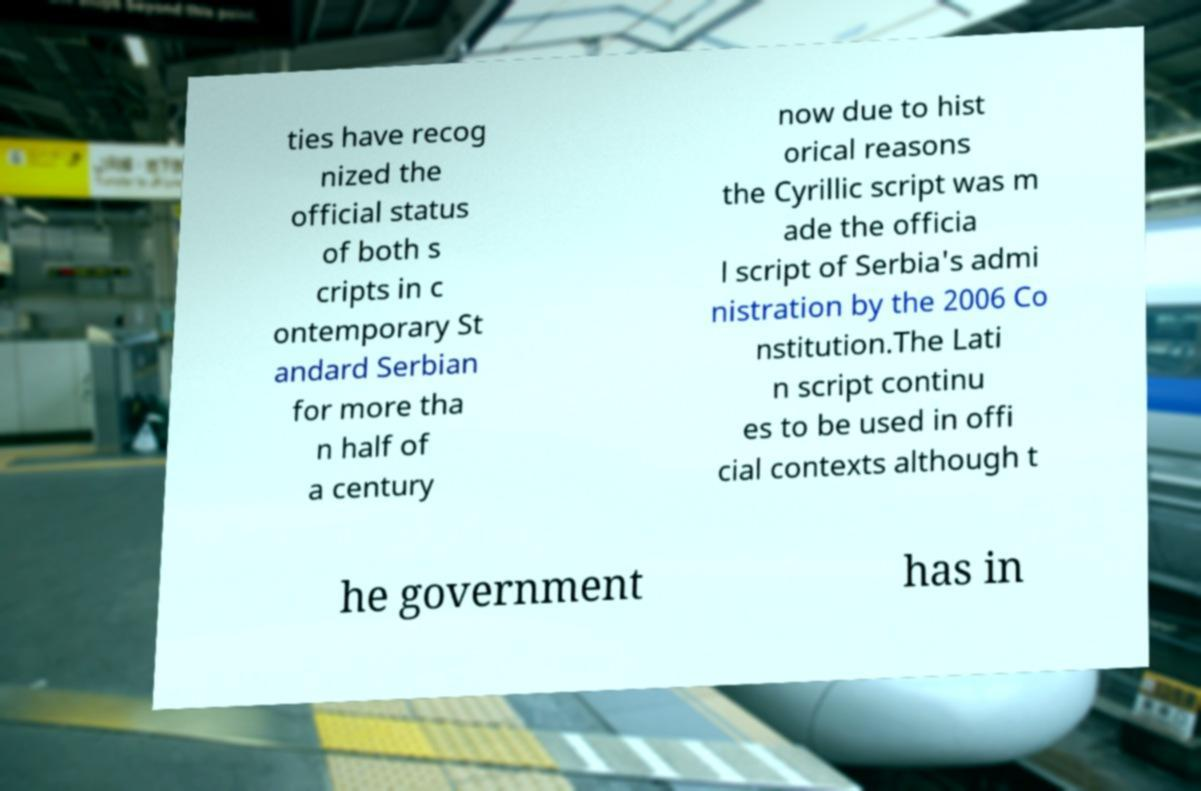What messages or text are displayed in this image? I need them in a readable, typed format. ties have recog nized the official status of both s cripts in c ontemporary St andard Serbian for more tha n half of a century now due to hist orical reasons the Cyrillic script was m ade the officia l script of Serbia's admi nistration by the 2006 Co nstitution.The Lati n script continu es to be used in offi cial contexts although t he government has in 